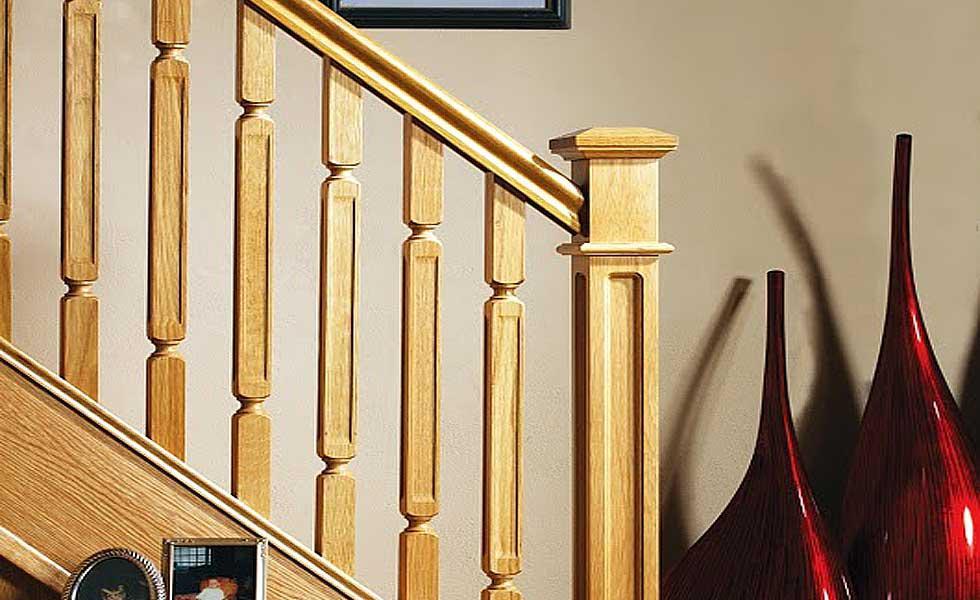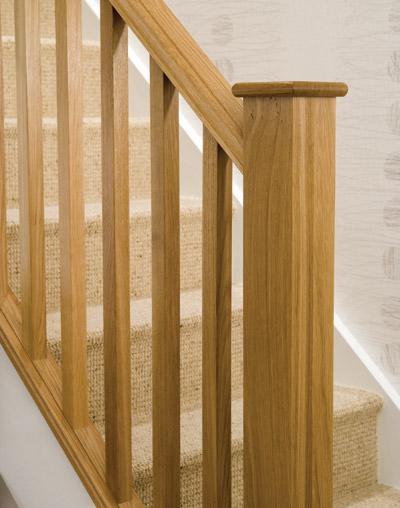The first image is the image on the left, the second image is the image on the right. Evaluate the accuracy of this statement regarding the images: "One image shows a wooden stair baluster with a silver cap, and vertical rails of twisted wood in front of gray carpeting.". Is it true? Answer yes or no. No. The first image is the image on the left, the second image is the image on the right. Evaluate the accuracy of this statement regarding the images: "In one of the images, the stairway post is made of wood and metal.". Is it true? Answer yes or no. No. 